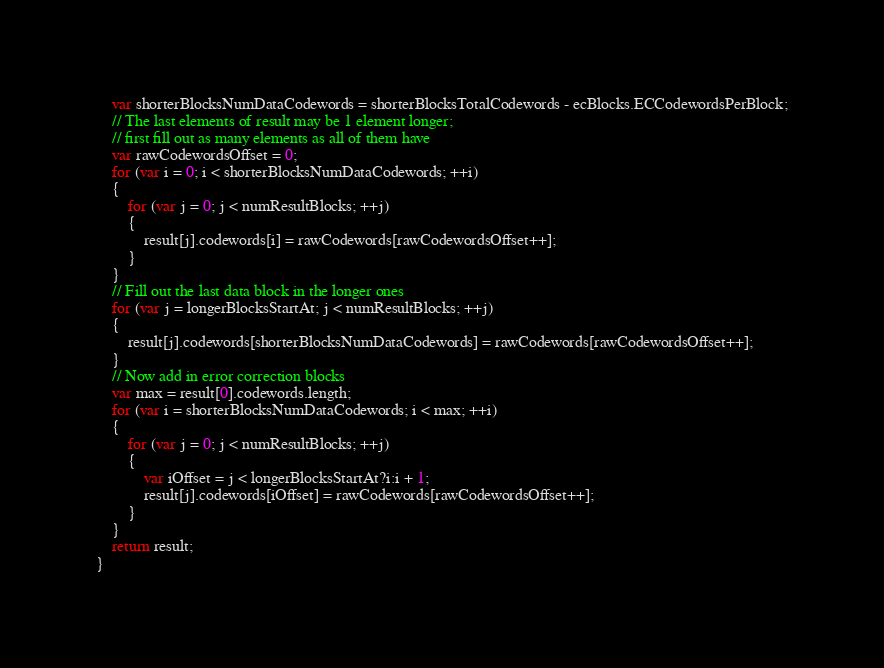<code> <loc_0><loc_0><loc_500><loc_500><_JavaScript_>	var shorterBlocksNumDataCodewords = shorterBlocksTotalCodewords - ecBlocks.ECCodewordsPerBlock;
	// The last elements of result may be 1 element longer;
	// first fill out as many elements as all of them have
	var rawCodewordsOffset = 0;
	for (var i = 0; i < shorterBlocksNumDataCodewords; ++i)
	{
		for (var j = 0; j < numResultBlocks; ++j)
		{
			result[j].codewords[i] = rawCodewords[rawCodewordsOffset++];
		}
	}
	// Fill out the last data block in the longer ones
	for (var j = longerBlocksStartAt; j < numResultBlocks; ++j)
	{
		result[j].codewords[shorterBlocksNumDataCodewords] = rawCodewords[rawCodewordsOffset++];
	}
	// Now add in error correction blocks
	var max = result[0].codewords.length;
	for (var i = shorterBlocksNumDataCodewords; i < max; ++i)
	{
		for (var j = 0; j < numResultBlocks; ++j)
		{
			var iOffset = j < longerBlocksStartAt?i:i + 1;
			result[j].codewords[iOffset] = rawCodewords[rawCodewordsOffset++];
		}
	}
	return result;
}
</code> 